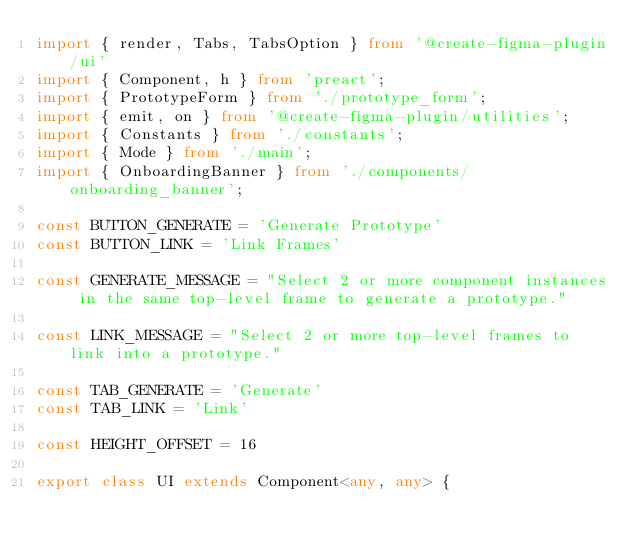Convert code to text. <code><loc_0><loc_0><loc_500><loc_500><_TypeScript_>import { render, Tabs, TabsOption } from '@create-figma-plugin/ui'
import { Component, h } from 'preact';
import { PrototypeForm } from './prototype_form';
import { emit, on } from '@create-figma-plugin/utilities';
import { Constants } from './constants';
import { Mode } from './main';
import { OnboardingBanner } from './components/onboarding_banner';

const BUTTON_GENERATE = 'Generate Prototype'
const BUTTON_LINK = 'Link Frames'

const GENERATE_MESSAGE = "Select 2 or more component instances in the same top-level frame to generate a prototype."

const LINK_MESSAGE = "Select 2 or more top-level frames to link into a prototype."

const TAB_GENERATE = 'Generate'
const TAB_LINK = 'Link'

const HEIGHT_OFFSET = 16

export class UI extends Component<any, any> {
</code> 